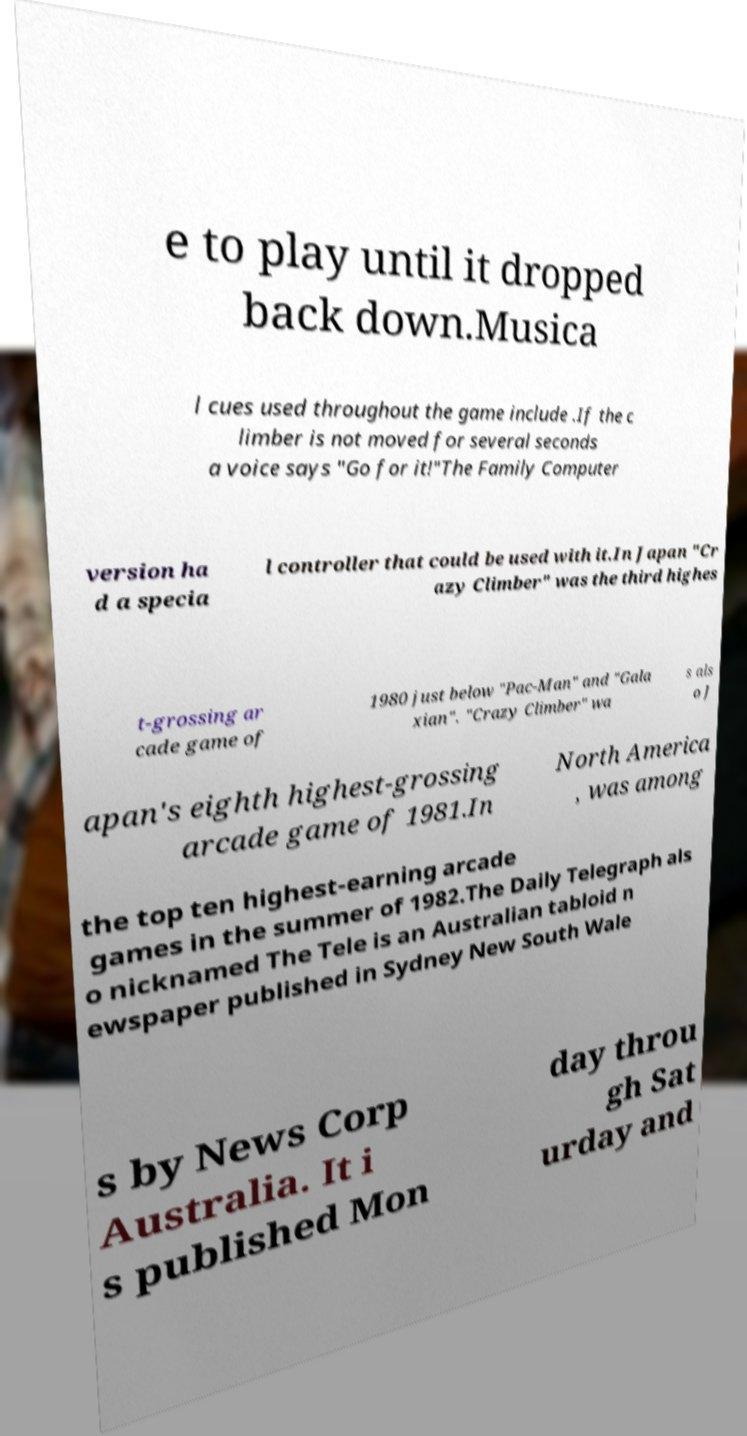Can you accurately transcribe the text from the provided image for me? e to play until it dropped back down.Musica l cues used throughout the game include .If the c limber is not moved for several seconds a voice says "Go for it!"The Family Computer version ha d a specia l controller that could be used with it.In Japan "Cr azy Climber" was the third highes t-grossing ar cade game of 1980 just below "Pac-Man" and "Gala xian". "Crazy Climber" wa s als o J apan's eighth highest-grossing arcade game of 1981.In North America , was among the top ten highest-earning arcade games in the summer of 1982.The Daily Telegraph als o nicknamed The Tele is an Australian tabloid n ewspaper published in Sydney New South Wale s by News Corp Australia. It i s published Mon day throu gh Sat urday and 